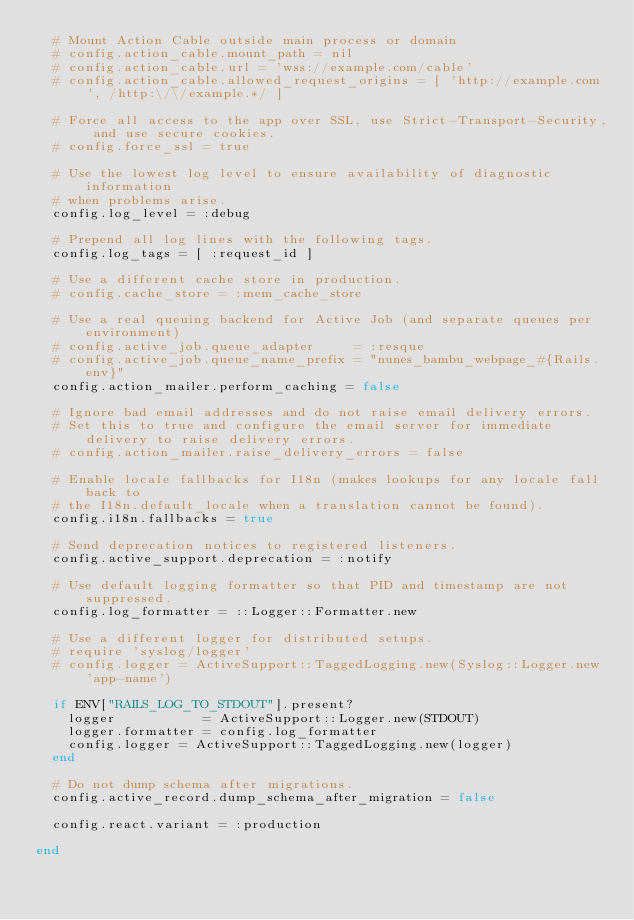<code> <loc_0><loc_0><loc_500><loc_500><_Ruby_>  # Mount Action Cable outside main process or domain
  # config.action_cable.mount_path = nil
  # config.action_cable.url = 'wss://example.com/cable'
  # config.action_cable.allowed_request_origins = [ 'http://example.com', /http:\/\/example.*/ ]

  # Force all access to the app over SSL, use Strict-Transport-Security, and use secure cookies.
  # config.force_ssl = true

  # Use the lowest log level to ensure availability of diagnostic information
  # when problems arise.
  config.log_level = :debug

  # Prepend all log lines with the following tags.
  config.log_tags = [ :request_id ]

  # Use a different cache store in production.
  # config.cache_store = :mem_cache_store

  # Use a real queuing backend for Active Job (and separate queues per environment)
  # config.active_job.queue_adapter     = :resque
  # config.active_job.queue_name_prefix = "nunes_bambu_webpage_#{Rails.env}"
  config.action_mailer.perform_caching = false

  # Ignore bad email addresses and do not raise email delivery errors.
  # Set this to true and configure the email server for immediate delivery to raise delivery errors.
  # config.action_mailer.raise_delivery_errors = false

  # Enable locale fallbacks for I18n (makes lookups for any locale fall back to
  # the I18n.default_locale when a translation cannot be found).
  config.i18n.fallbacks = true

  # Send deprecation notices to registered listeners.
  config.active_support.deprecation = :notify

  # Use default logging formatter so that PID and timestamp are not suppressed.
  config.log_formatter = ::Logger::Formatter.new

  # Use a different logger for distributed setups.
  # require 'syslog/logger'
  # config.logger = ActiveSupport::TaggedLogging.new(Syslog::Logger.new 'app-name')

  if ENV["RAILS_LOG_TO_STDOUT"].present?
    logger           = ActiveSupport::Logger.new(STDOUT)
    logger.formatter = config.log_formatter
    config.logger = ActiveSupport::TaggedLogging.new(logger)
  end

  # Do not dump schema after migrations.
  config.active_record.dump_schema_after_migration = false
  
  config.react.variant = :production
  
end
</code> 